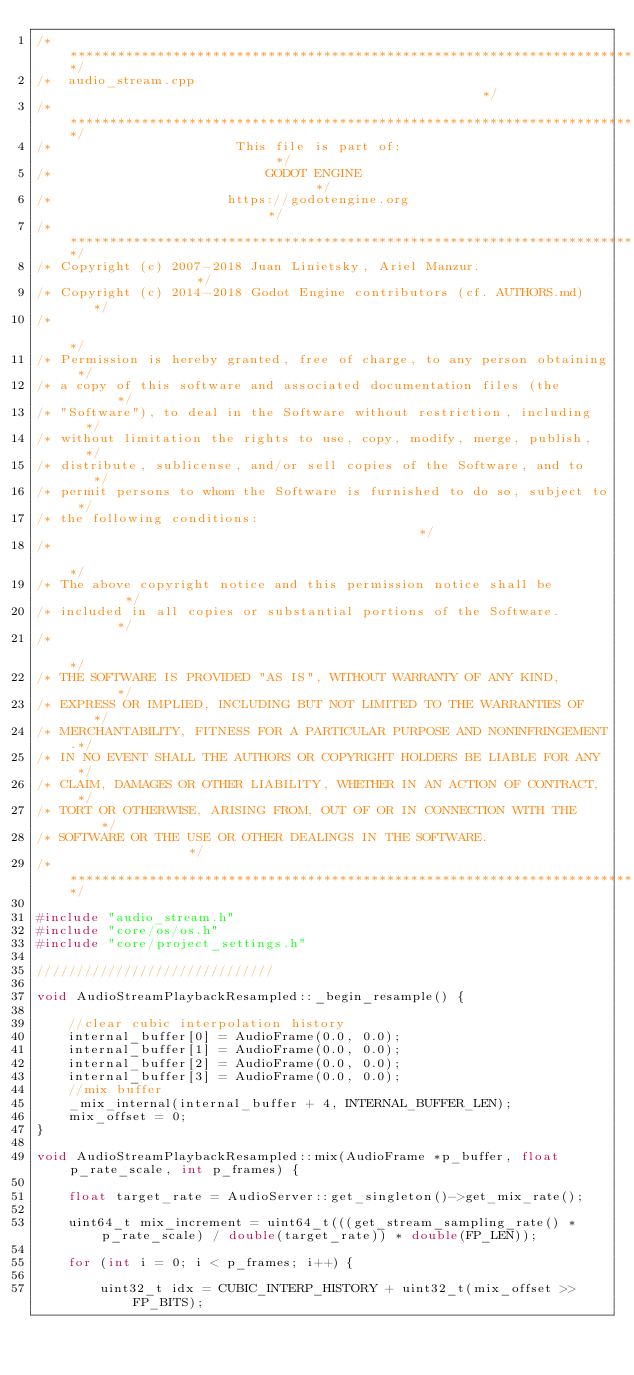Convert code to text. <code><loc_0><loc_0><loc_500><loc_500><_C++_>/*************************************************************************/
/*  audio_stream.cpp                                                     */
/*************************************************************************/
/*                       This file is part of:                           */
/*                           GODOT ENGINE                                */
/*                      https://godotengine.org                          */
/*************************************************************************/
/* Copyright (c) 2007-2018 Juan Linietsky, Ariel Manzur.                 */
/* Copyright (c) 2014-2018 Godot Engine contributors (cf. AUTHORS.md)    */
/*                                                                       */
/* Permission is hereby granted, free of charge, to any person obtaining */
/* a copy of this software and associated documentation files (the       */
/* "Software"), to deal in the Software without restriction, including   */
/* without limitation the rights to use, copy, modify, merge, publish,   */
/* distribute, sublicense, and/or sell copies of the Software, and to    */
/* permit persons to whom the Software is furnished to do so, subject to */
/* the following conditions:                                             */
/*                                                                       */
/* The above copyright notice and this permission notice shall be        */
/* included in all copies or substantial portions of the Software.       */
/*                                                                       */
/* THE SOFTWARE IS PROVIDED "AS IS", WITHOUT WARRANTY OF ANY KIND,       */
/* EXPRESS OR IMPLIED, INCLUDING BUT NOT LIMITED TO THE WARRANTIES OF    */
/* MERCHANTABILITY, FITNESS FOR A PARTICULAR PURPOSE AND NONINFRINGEMENT.*/
/* IN NO EVENT SHALL THE AUTHORS OR COPYRIGHT HOLDERS BE LIABLE FOR ANY  */
/* CLAIM, DAMAGES OR OTHER LIABILITY, WHETHER IN AN ACTION OF CONTRACT,  */
/* TORT OR OTHERWISE, ARISING FROM, OUT OF OR IN CONNECTION WITH THE     */
/* SOFTWARE OR THE USE OR OTHER DEALINGS IN THE SOFTWARE.                */
/*************************************************************************/

#include "audio_stream.h"
#include "core/os/os.h"
#include "core/project_settings.h"

//////////////////////////////

void AudioStreamPlaybackResampled::_begin_resample() {

	//clear cubic interpolation history
	internal_buffer[0] = AudioFrame(0.0, 0.0);
	internal_buffer[1] = AudioFrame(0.0, 0.0);
	internal_buffer[2] = AudioFrame(0.0, 0.0);
	internal_buffer[3] = AudioFrame(0.0, 0.0);
	//mix buffer
	_mix_internal(internal_buffer + 4, INTERNAL_BUFFER_LEN);
	mix_offset = 0;
}

void AudioStreamPlaybackResampled::mix(AudioFrame *p_buffer, float p_rate_scale, int p_frames) {

	float target_rate = AudioServer::get_singleton()->get_mix_rate();

	uint64_t mix_increment = uint64_t(((get_stream_sampling_rate() * p_rate_scale) / double(target_rate)) * double(FP_LEN));

	for (int i = 0; i < p_frames; i++) {

		uint32_t idx = CUBIC_INTERP_HISTORY + uint32_t(mix_offset >> FP_BITS);</code> 